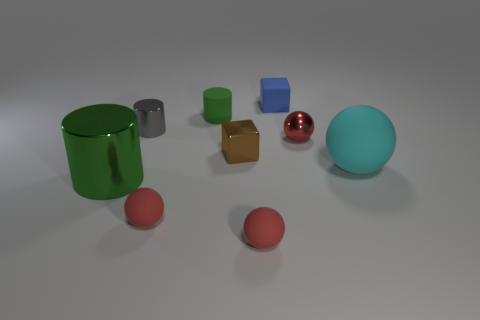What number of small red things are the same shape as the large cyan object?
Your answer should be very brief. 3. Is the number of small matte objects that are in front of the large rubber sphere greater than the number of cyan matte objects?
Provide a succinct answer. Yes. What shape is the small matte thing that is to the right of the small green matte thing and behind the large matte thing?
Your response must be concise. Cube. Does the brown cube have the same size as the red metallic ball?
Offer a very short reply. Yes. How many matte things are in front of the cyan rubber ball?
Provide a short and direct response. 2. Are there the same number of small blue rubber blocks left of the gray metal object and large things that are to the left of the green rubber object?
Provide a succinct answer. No. There is a shiny thing to the left of the tiny metallic cylinder; is it the same shape as the gray metallic thing?
Offer a terse response. Yes. There is a green matte cylinder; is it the same size as the rubber ball on the right side of the metal sphere?
Your response must be concise. No. What number of other objects are the same color as the small rubber cylinder?
Make the answer very short. 1. There is a gray object; are there any cylinders to the left of it?
Provide a succinct answer. Yes. 